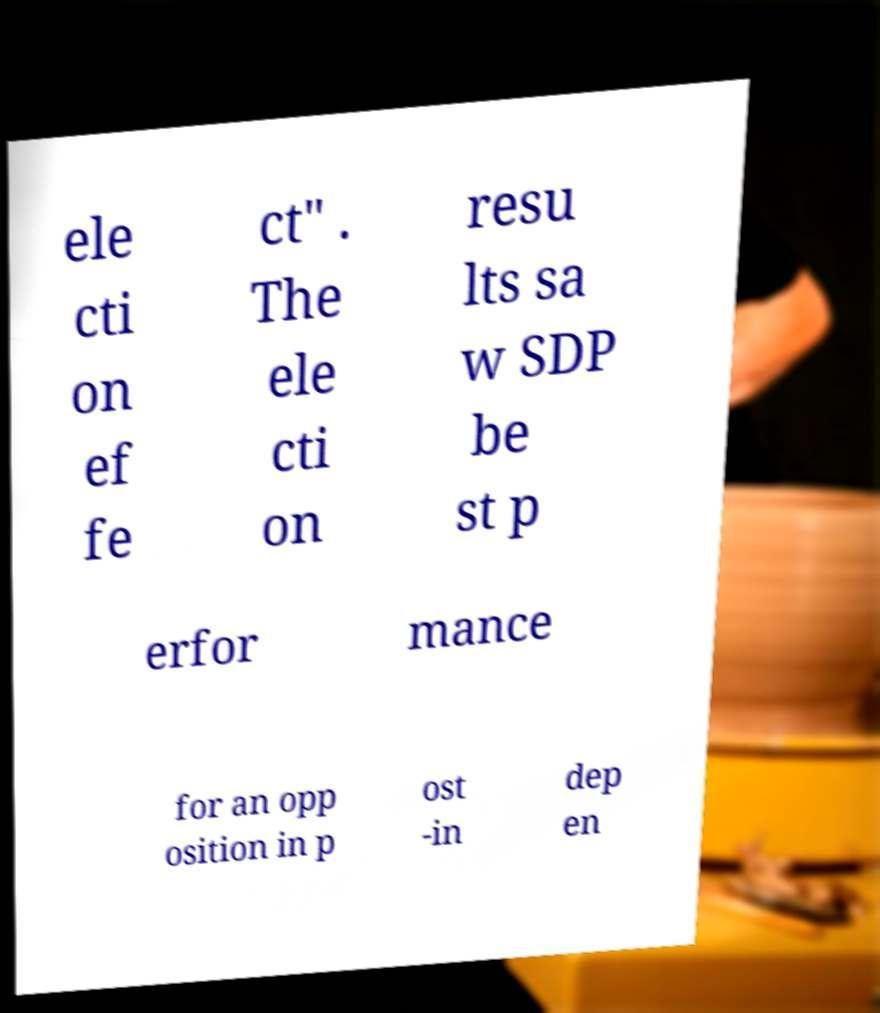Could you assist in decoding the text presented in this image and type it out clearly? ele cti on ef fe ct" . The ele cti on resu lts sa w SDP be st p erfor mance for an opp osition in p ost -in dep en 